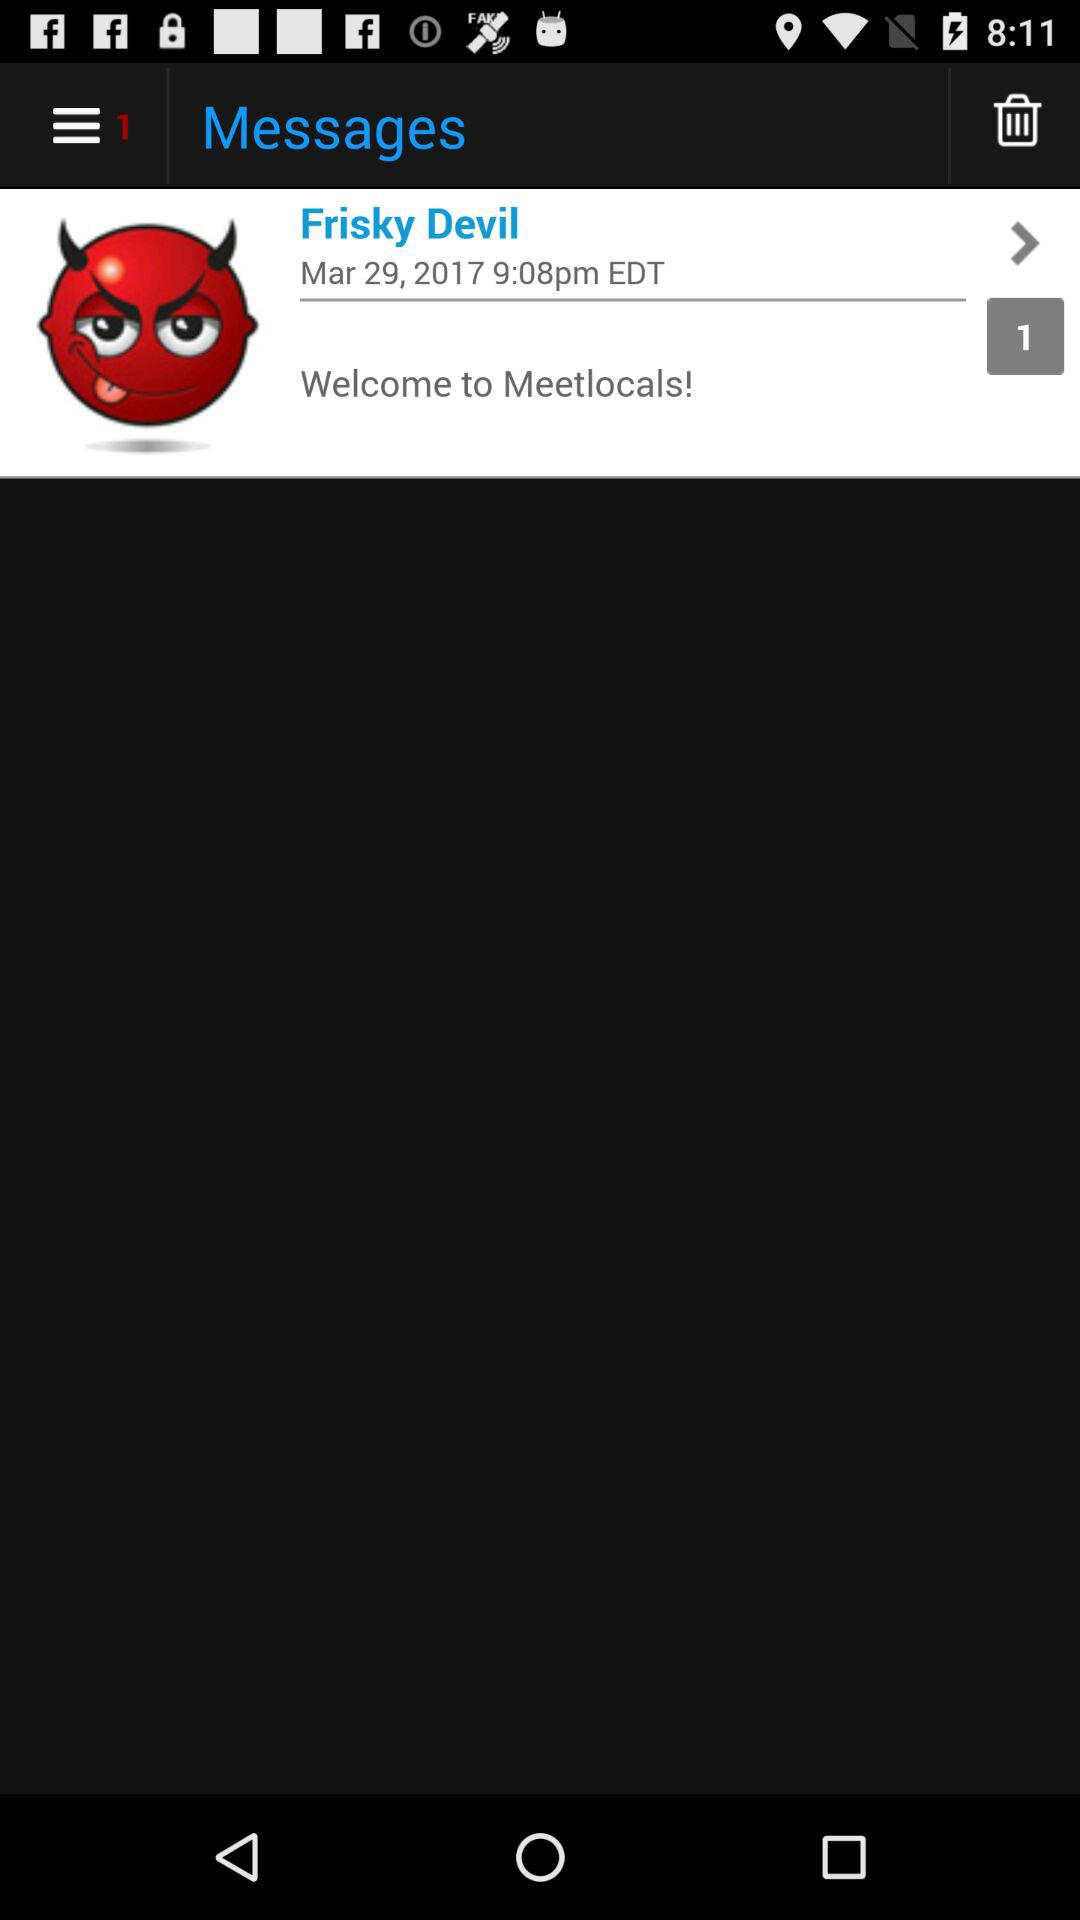How many item are in the trash?
When the provided information is insufficient, respond with <no answer>. <no answer> 